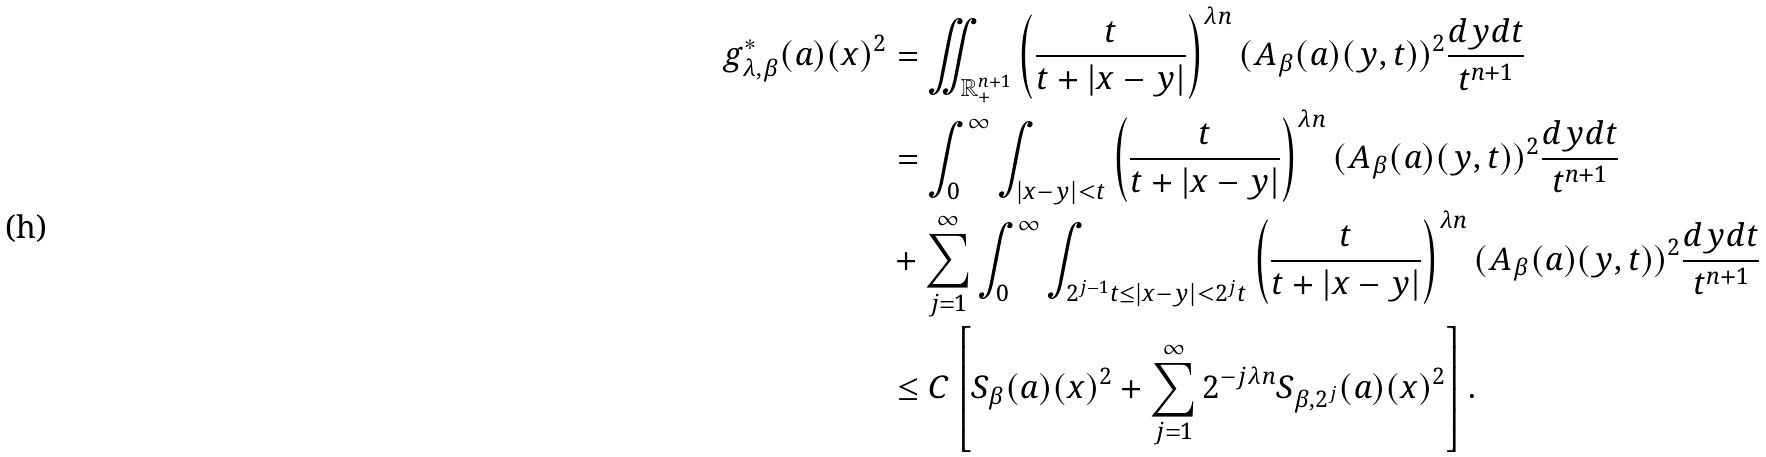<formula> <loc_0><loc_0><loc_500><loc_500>g ^ { * } _ { \lambda , \beta } ( a ) ( x ) ^ { 2 } & = \iint _ { \mathbb { R } ^ { n + 1 } _ { + } } \left ( \frac { t } { t + | x - y | } \right ) ^ { \lambda n } ( A _ { \beta } ( a ) ( y , t ) ) ^ { 2 } \frac { d y d t } { t ^ { n + 1 } } \\ & = \int _ { 0 } ^ { \infty } \int _ { | x - y | < t } \left ( \frac { t } { t + | x - y | } \right ) ^ { \lambda n } ( A _ { \beta } ( a ) ( y , t ) ) ^ { 2 } \frac { d y d t } { t ^ { n + 1 } } \\ & + \sum _ { j = 1 } ^ { \infty } \int _ { 0 } ^ { \infty } \int _ { 2 ^ { j - 1 } t \leq | x - y | < 2 ^ { j } t } \left ( \frac { t } { t + | x - y | } \right ) ^ { \lambda n } ( A _ { \beta } ( a ) ( y , t ) ) ^ { 2 } \frac { d y d t } { t ^ { n + 1 } } \\ & \leq C \left [ S _ { \beta } ( a ) ( x ) ^ { 2 } + \sum _ { j = 1 } ^ { \infty } 2 ^ { - j \lambda n } S _ { \beta , 2 ^ { j } } ( a ) ( x ) ^ { 2 } \right ] .</formula> 